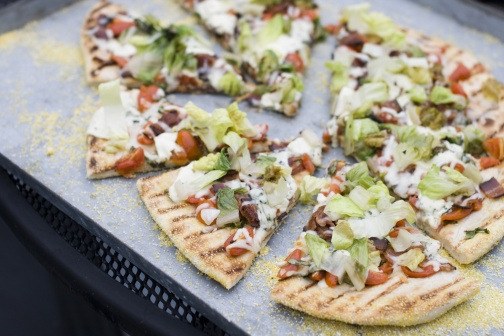Can you describe the arrangement of the pizza slices? The pizza slices are meticulously arranged in a circular pattern on a black tray, similar to the rays of a sun or the spokes of a wheel. Each slice radiates outwards from the central point of the pizza, evenly spaced to ensure a balanced presentation. The uniformity in the cut and the spread of toppings speaks of a careful and deliberate arrangement that accentuates the pizza's visual appeal, inviting the viewer to reach out and grab a slice. In what kind of event do you think this pizza would be most appreciated? This pizza would be a star attraction at any casual gathering or celebration, such as a garden party, family reunion, or weekend get-together. Its vibrant and fresh toppings make it perfect for a summer picnic, where guests can enjoy the lively mix of flavors in the outdoor air. Additionally, its appetizing presentation would make it a hit at a themed party or culinary event, where the emphasis is on enjoying high-quality, artisanal food in good company. Imagine this pizza being the winner of a most creative pizza contest. In the bustling heart of the city's annual culinary festival, 'The Great Pizza Challenge' was in full swing. The competition was fierce, with innovative creations from renowned chefs around the world. However, the judges were particularly taken by one entry, 'The Harvest Harmony.' The pizza, laden with a vibrant array of fresh, organic toppings, was a celebration of nature's bounty. The meticulous arrangement and perfect balance of flavors showcased not just culinary expertise but also an artistic touch. The crust, with its perfect bake and subtle grill marks, was the ideal foundation for the masterpiece. As the judges deliberated, tasting each slice, the harmonious blend of textures and flavors won them over. 'The Harvest Harmony' was crowned the winner, and its creator was celebrated not just as a chef, but as an artist who had successfully captured the essence of nature and community in every bite. 